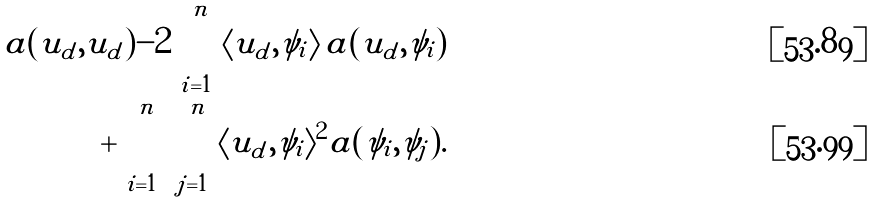<formula> <loc_0><loc_0><loc_500><loc_500>a ( u _ { d } , u _ { d } ) - 2 \sum _ { i = 1 } ^ { n } \langle u _ { d } , \psi _ { i } \rangle \, a ( u _ { d } , \psi _ { i } ) \\ + \sum _ { i = 1 } ^ { n } \sum _ { j = 1 } ^ { n } \langle u _ { d } , \psi _ { i } \rangle ^ { 2 } a ( \psi _ { i } , \psi _ { j } ) .</formula> 